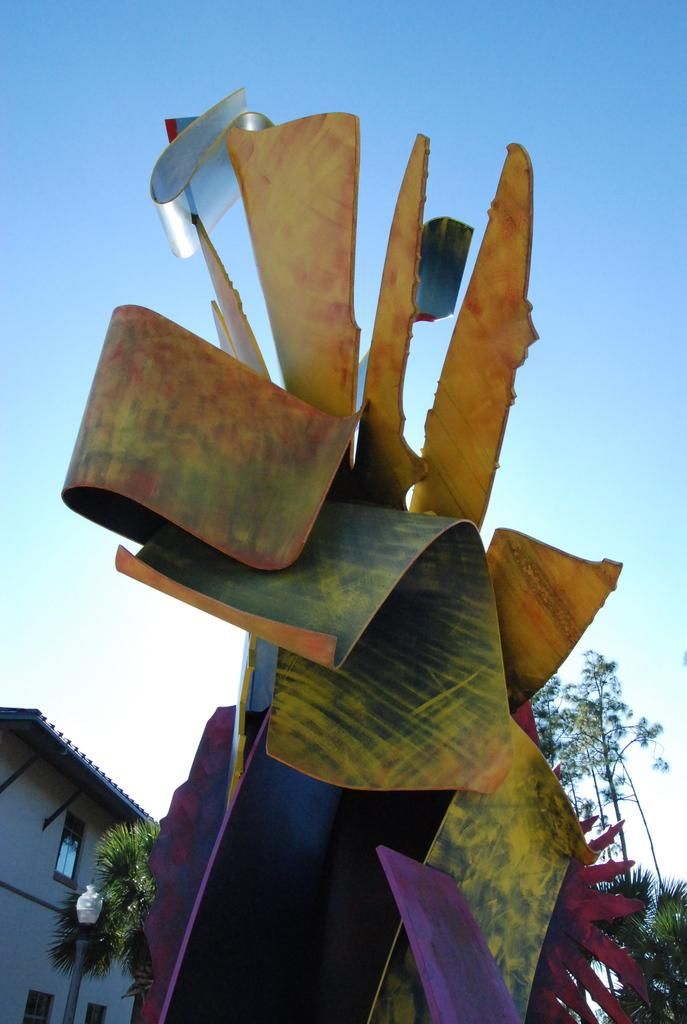What is the main subject of the image? There is a sculpture in the image. What can be seen in the background of the image? There are trees, a house, and the sky visible in the background of the image. How many dogs are running in the field in the image? There are no dogs or fields present in the image; it features a sculpture and background elements such as trees, a house, and the sky. 